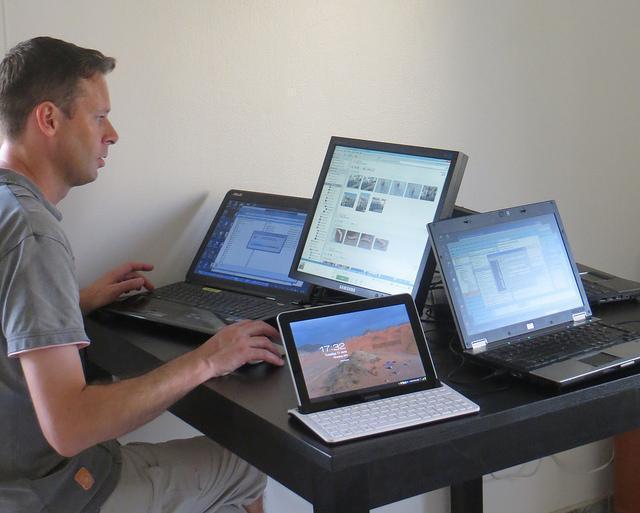How many laptop computers in this picture?
Give a very brief answer. 4. How many computers?
Give a very brief answer. 4. How many laptops can you see?
Give a very brief answer. 3. How many keyboards are visible?
Give a very brief answer. 2. How many motorcycles are there in the image?
Give a very brief answer. 0. 